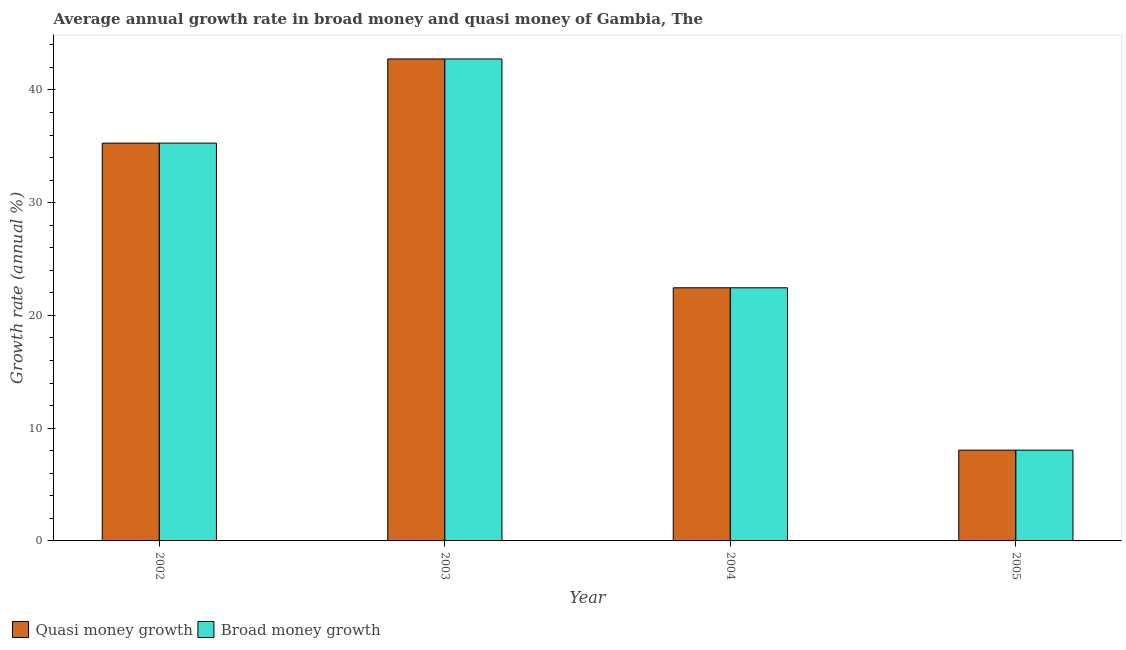Are the number of bars per tick equal to the number of legend labels?
Keep it short and to the point. Yes. How many bars are there on the 3rd tick from the left?
Offer a terse response. 2. How many bars are there on the 2nd tick from the right?
Your response must be concise. 2. What is the label of the 4th group of bars from the left?
Provide a succinct answer. 2005. In how many cases, is the number of bars for a given year not equal to the number of legend labels?
Ensure brevity in your answer.  0. What is the annual growth rate in broad money in 2003?
Your answer should be very brief. 42.74. Across all years, what is the maximum annual growth rate in quasi money?
Give a very brief answer. 42.74. Across all years, what is the minimum annual growth rate in broad money?
Your response must be concise. 8.05. In which year was the annual growth rate in broad money maximum?
Provide a short and direct response. 2003. In which year was the annual growth rate in broad money minimum?
Give a very brief answer. 2005. What is the total annual growth rate in broad money in the graph?
Provide a succinct answer. 108.53. What is the difference between the annual growth rate in broad money in 2002 and that in 2004?
Your response must be concise. 12.83. What is the difference between the annual growth rate in broad money in 2005 and the annual growth rate in quasi money in 2002?
Your response must be concise. -27.23. What is the average annual growth rate in broad money per year?
Ensure brevity in your answer.  27.13. In how many years, is the annual growth rate in quasi money greater than 30 %?
Your response must be concise. 2. What is the ratio of the annual growth rate in quasi money in 2004 to that in 2005?
Make the answer very short. 2.79. Is the difference between the annual growth rate in quasi money in 2003 and 2004 greater than the difference between the annual growth rate in broad money in 2003 and 2004?
Keep it short and to the point. No. What is the difference between the highest and the second highest annual growth rate in broad money?
Offer a very short reply. 7.46. What is the difference between the highest and the lowest annual growth rate in broad money?
Make the answer very short. 34.69. Is the sum of the annual growth rate in broad money in 2004 and 2005 greater than the maximum annual growth rate in quasi money across all years?
Give a very brief answer. No. What does the 2nd bar from the left in 2003 represents?
Your response must be concise. Broad money growth. What does the 1st bar from the right in 2004 represents?
Make the answer very short. Broad money growth. How many bars are there?
Keep it short and to the point. 8. Are the values on the major ticks of Y-axis written in scientific E-notation?
Ensure brevity in your answer.  No. Does the graph contain any zero values?
Give a very brief answer. No. Does the graph contain grids?
Ensure brevity in your answer.  No. How many legend labels are there?
Ensure brevity in your answer.  2. How are the legend labels stacked?
Your answer should be compact. Horizontal. What is the title of the graph?
Your answer should be compact. Average annual growth rate in broad money and quasi money of Gambia, The. Does "Education" appear as one of the legend labels in the graph?
Provide a succinct answer. No. What is the label or title of the X-axis?
Offer a terse response. Year. What is the label or title of the Y-axis?
Offer a terse response. Growth rate (annual %). What is the Growth rate (annual %) of Quasi money growth in 2002?
Your response must be concise. 35.28. What is the Growth rate (annual %) of Broad money growth in 2002?
Provide a short and direct response. 35.28. What is the Growth rate (annual %) of Quasi money growth in 2003?
Your answer should be very brief. 42.74. What is the Growth rate (annual %) in Broad money growth in 2003?
Ensure brevity in your answer.  42.74. What is the Growth rate (annual %) of Quasi money growth in 2004?
Your answer should be compact. 22.45. What is the Growth rate (annual %) in Broad money growth in 2004?
Offer a terse response. 22.45. What is the Growth rate (annual %) of Quasi money growth in 2005?
Ensure brevity in your answer.  8.05. What is the Growth rate (annual %) of Broad money growth in 2005?
Your answer should be very brief. 8.05. Across all years, what is the maximum Growth rate (annual %) in Quasi money growth?
Your response must be concise. 42.74. Across all years, what is the maximum Growth rate (annual %) of Broad money growth?
Make the answer very short. 42.74. Across all years, what is the minimum Growth rate (annual %) in Quasi money growth?
Offer a very short reply. 8.05. Across all years, what is the minimum Growth rate (annual %) in Broad money growth?
Provide a succinct answer. 8.05. What is the total Growth rate (annual %) of Quasi money growth in the graph?
Provide a succinct answer. 108.53. What is the total Growth rate (annual %) of Broad money growth in the graph?
Give a very brief answer. 108.53. What is the difference between the Growth rate (annual %) in Quasi money growth in 2002 and that in 2003?
Offer a very short reply. -7.46. What is the difference between the Growth rate (annual %) in Broad money growth in 2002 and that in 2003?
Make the answer very short. -7.46. What is the difference between the Growth rate (annual %) of Quasi money growth in 2002 and that in 2004?
Offer a very short reply. 12.83. What is the difference between the Growth rate (annual %) of Broad money growth in 2002 and that in 2004?
Keep it short and to the point. 12.83. What is the difference between the Growth rate (annual %) of Quasi money growth in 2002 and that in 2005?
Offer a very short reply. 27.23. What is the difference between the Growth rate (annual %) in Broad money growth in 2002 and that in 2005?
Offer a very short reply. 27.23. What is the difference between the Growth rate (annual %) in Quasi money growth in 2003 and that in 2004?
Your response must be concise. 20.29. What is the difference between the Growth rate (annual %) of Broad money growth in 2003 and that in 2004?
Your response must be concise. 20.29. What is the difference between the Growth rate (annual %) of Quasi money growth in 2003 and that in 2005?
Give a very brief answer. 34.69. What is the difference between the Growth rate (annual %) of Broad money growth in 2003 and that in 2005?
Make the answer very short. 34.69. What is the difference between the Growth rate (annual %) in Quasi money growth in 2004 and that in 2005?
Provide a succinct answer. 14.4. What is the difference between the Growth rate (annual %) in Broad money growth in 2004 and that in 2005?
Make the answer very short. 14.4. What is the difference between the Growth rate (annual %) of Quasi money growth in 2002 and the Growth rate (annual %) of Broad money growth in 2003?
Ensure brevity in your answer.  -7.46. What is the difference between the Growth rate (annual %) of Quasi money growth in 2002 and the Growth rate (annual %) of Broad money growth in 2004?
Your answer should be compact. 12.83. What is the difference between the Growth rate (annual %) in Quasi money growth in 2002 and the Growth rate (annual %) in Broad money growth in 2005?
Your response must be concise. 27.23. What is the difference between the Growth rate (annual %) in Quasi money growth in 2003 and the Growth rate (annual %) in Broad money growth in 2004?
Offer a terse response. 20.29. What is the difference between the Growth rate (annual %) of Quasi money growth in 2003 and the Growth rate (annual %) of Broad money growth in 2005?
Provide a succinct answer. 34.69. What is the difference between the Growth rate (annual %) in Quasi money growth in 2004 and the Growth rate (annual %) in Broad money growth in 2005?
Give a very brief answer. 14.4. What is the average Growth rate (annual %) in Quasi money growth per year?
Make the answer very short. 27.13. What is the average Growth rate (annual %) of Broad money growth per year?
Offer a very short reply. 27.13. In the year 2004, what is the difference between the Growth rate (annual %) of Quasi money growth and Growth rate (annual %) of Broad money growth?
Keep it short and to the point. 0. In the year 2005, what is the difference between the Growth rate (annual %) of Quasi money growth and Growth rate (annual %) of Broad money growth?
Give a very brief answer. 0. What is the ratio of the Growth rate (annual %) of Quasi money growth in 2002 to that in 2003?
Offer a terse response. 0.83. What is the ratio of the Growth rate (annual %) in Broad money growth in 2002 to that in 2003?
Offer a terse response. 0.83. What is the ratio of the Growth rate (annual %) of Quasi money growth in 2002 to that in 2004?
Provide a succinct answer. 1.57. What is the ratio of the Growth rate (annual %) of Broad money growth in 2002 to that in 2004?
Make the answer very short. 1.57. What is the ratio of the Growth rate (annual %) in Quasi money growth in 2002 to that in 2005?
Your answer should be compact. 4.38. What is the ratio of the Growth rate (annual %) in Broad money growth in 2002 to that in 2005?
Your response must be concise. 4.38. What is the ratio of the Growth rate (annual %) in Quasi money growth in 2003 to that in 2004?
Give a very brief answer. 1.9. What is the ratio of the Growth rate (annual %) of Broad money growth in 2003 to that in 2004?
Keep it short and to the point. 1.9. What is the ratio of the Growth rate (annual %) in Quasi money growth in 2003 to that in 2005?
Offer a very short reply. 5.31. What is the ratio of the Growth rate (annual %) in Broad money growth in 2003 to that in 2005?
Offer a terse response. 5.31. What is the ratio of the Growth rate (annual %) of Quasi money growth in 2004 to that in 2005?
Offer a very short reply. 2.79. What is the ratio of the Growth rate (annual %) of Broad money growth in 2004 to that in 2005?
Provide a short and direct response. 2.79. What is the difference between the highest and the second highest Growth rate (annual %) in Quasi money growth?
Offer a very short reply. 7.46. What is the difference between the highest and the second highest Growth rate (annual %) of Broad money growth?
Provide a succinct answer. 7.46. What is the difference between the highest and the lowest Growth rate (annual %) of Quasi money growth?
Your answer should be very brief. 34.69. What is the difference between the highest and the lowest Growth rate (annual %) of Broad money growth?
Provide a succinct answer. 34.69. 